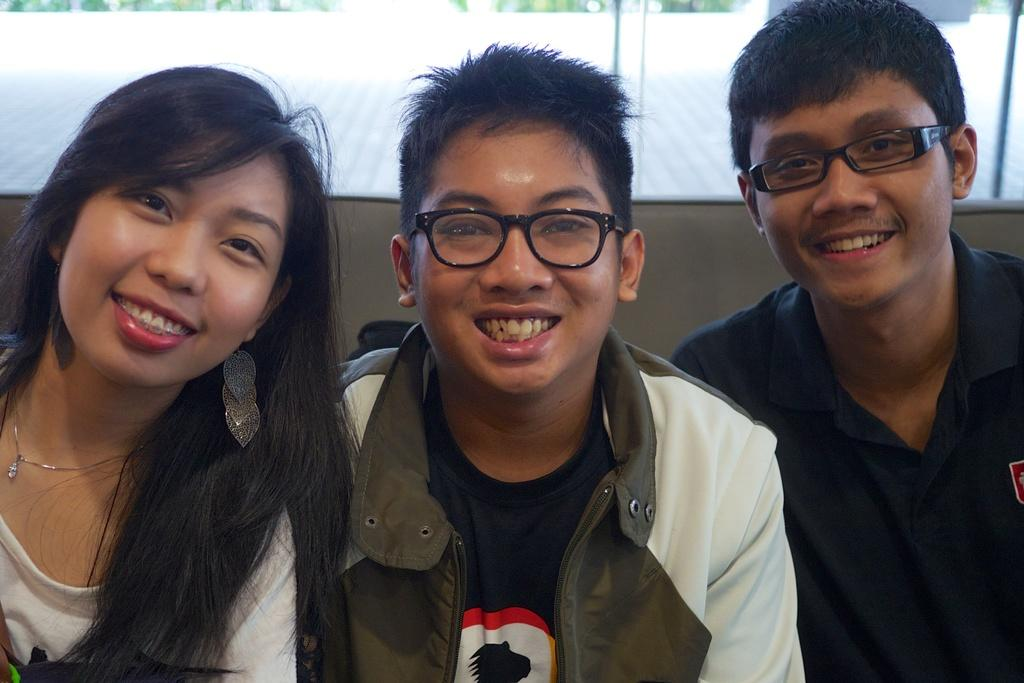How many people are in the image? There are three persons in the image. Can you describe the clothing of one of the persons? One person is wearing a dress with black, white, and brown colors. What can be seen in the background of the image? There is a glass wall in the background of the image. What type of flame can be seen coming from the person's hand in the image? There is no flame present in the image; it features three persons and a glass wall in the background. How many songs are being sung by the persons in the image? There is no indication in the image that the persons are singing songs, so it cannot be determined from the picture. 